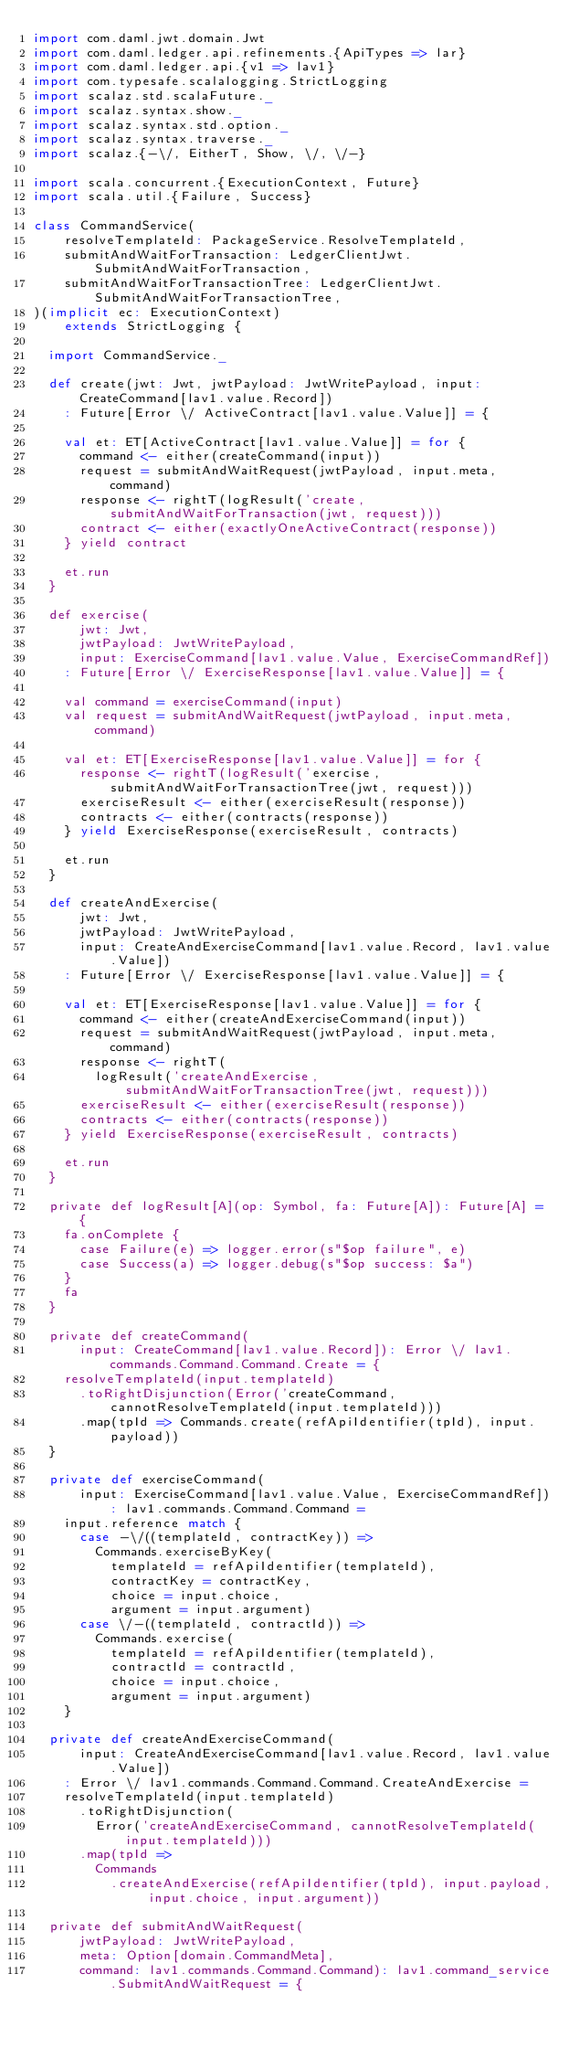Convert code to text. <code><loc_0><loc_0><loc_500><loc_500><_Scala_>import com.daml.jwt.domain.Jwt
import com.daml.ledger.api.refinements.{ApiTypes => lar}
import com.daml.ledger.api.{v1 => lav1}
import com.typesafe.scalalogging.StrictLogging
import scalaz.std.scalaFuture._
import scalaz.syntax.show._
import scalaz.syntax.std.option._
import scalaz.syntax.traverse._
import scalaz.{-\/, EitherT, Show, \/, \/-}

import scala.concurrent.{ExecutionContext, Future}
import scala.util.{Failure, Success}

class CommandService(
    resolveTemplateId: PackageService.ResolveTemplateId,
    submitAndWaitForTransaction: LedgerClientJwt.SubmitAndWaitForTransaction,
    submitAndWaitForTransactionTree: LedgerClientJwt.SubmitAndWaitForTransactionTree,
)(implicit ec: ExecutionContext)
    extends StrictLogging {

  import CommandService._

  def create(jwt: Jwt, jwtPayload: JwtWritePayload, input: CreateCommand[lav1.value.Record])
    : Future[Error \/ ActiveContract[lav1.value.Value]] = {

    val et: ET[ActiveContract[lav1.value.Value]] = for {
      command <- either(createCommand(input))
      request = submitAndWaitRequest(jwtPayload, input.meta, command)
      response <- rightT(logResult('create, submitAndWaitForTransaction(jwt, request)))
      contract <- either(exactlyOneActiveContract(response))
    } yield contract

    et.run
  }

  def exercise(
      jwt: Jwt,
      jwtPayload: JwtWritePayload,
      input: ExerciseCommand[lav1.value.Value, ExerciseCommandRef])
    : Future[Error \/ ExerciseResponse[lav1.value.Value]] = {

    val command = exerciseCommand(input)
    val request = submitAndWaitRequest(jwtPayload, input.meta, command)

    val et: ET[ExerciseResponse[lav1.value.Value]] = for {
      response <- rightT(logResult('exercise, submitAndWaitForTransactionTree(jwt, request)))
      exerciseResult <- either(exerciseResult(response))
      contracts <- either(contracts(response))
    } yield ExerciseResponse(exerciseResult, contracts)

    et.run
  }

  def createAndExercise(
      jwt: Jwt,
      jwtPayload: JwtWritePayload,
      input: CreateAndExerciseCommand[lav1.value.Record, lav1.value.Value])
    : Future[Error \/ ExerciseResponse[lav1.value.Value]] = {

    val et: ET[ExerciseResponse[lav1.value.Value]] = for {
      command <- either(createAndExerciseCommand(input))
      request = submitAndWaitRequest(jwtPayload, input.meta, command)
      response <- rightT(
        logResult('createAndExercise, submitAndWaitForTransactionTree(jwt, request)))
      exerciseResult <- either(exerciseResult(response))
      contracts <- either(contracts(response))
    } yield ExerciseResponse(exerciseResult, contracts)

    et.run
  }

  private def logResult[A](op: Symbol, fa: Future[A]): Future[A] = {
    fa.onComplete {
      case Failure(e) => logger.error(s"$op failure", e)
      case Success(a) => logger.debug(s"$op success: $a")
    }
    fa
  }

  private def createCommand(
      input: CreateCommand[lav1.value.Record]): Error \/ lav1.commands.Command.Command.Create = {
    resolveTemplateId(input.templateId)
      .toRightDisjunction(Error('createCommand, cannotResolveTemplateId(input.templateId)))
      .map(tpId => Commands.create(refApiIdentifier(tpId), input.payload))
  }

  private def exerciseCommand(
      input: ExerciseCommand[lav1.value.Value, ExerciseCommandRef]): lav1.commands.Command.Command =
    input.reference match {
      case -\/((templateId, contractKey)) =>
        Commands.exerciseByKey(
          templateId = refApiIdentifier(templateId),
          contractKey = contractKey,
          choice = input.choice,
          argument = input.argument)
      case \/-((templateId, contractId)) =>
        Commands.exercise(
          templateId = refApiIdentifier(templateId),
          contractId = contractId,
          choice = input.choice,
          argument = input.argument)
    }

  private def createAndExerciseCommand(
      input: CreateAndExerciseCommand[lav1.value.Record, lav1.value.Value])
    : Error \/ lav1.commands.Command.Command.CreateAndExercise =
    resolveTemplateId(input.templateId)
      .toRightDisjunction(
        Error('createAndExerciseCommand, cannotResolveTemplateId(input.templateId)))
      .map(tpId =>
        Commands
          .createAndExercise(refApiIdentifier(tpId), input.payload, input.choice, input.argument))

  private def submitAndWaitRequest(
      jwtPayload: JwtWritePayload,
      meta: Option[domain.CommandMeta],
      command: lav1.commands.Command.Command): lav1.command_service.SubmitAndWaitRequest = {
</code> 